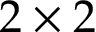<formula> <loc_0><loc_0><loc_500><loc_500>2 \times 2</formula> 